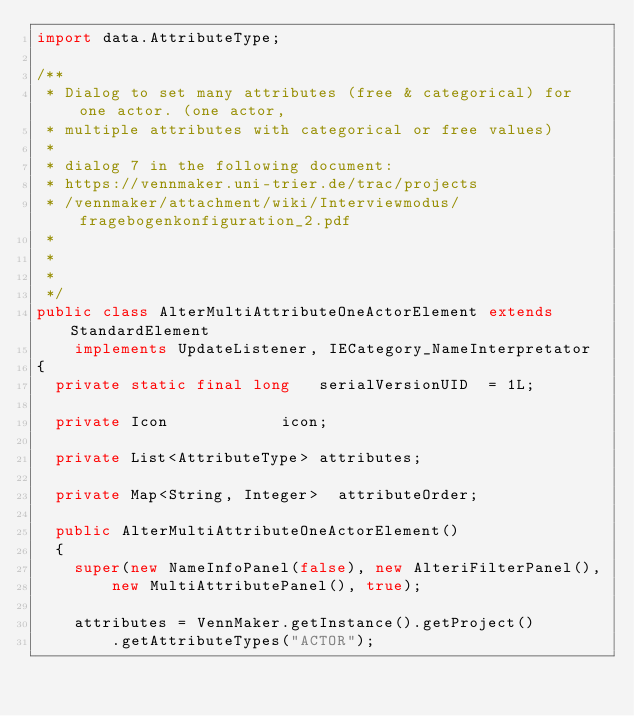<code> <loc_0><loc_0><loc_500><loc_500><_Java_>import data.AttributeType;

/**
 * Dialog to set many attributes (free & categorical) for one actor. (one actor,
 * multiple attributes with categorical or free values)
 * 
 * dialog 7 in the following document:
 * https://vennmaker.uni-trier.de/trac/projects
 * /vennmaker/attachment/wiki/Interviewmodus/fragebogenkonfiguration_2.pdf
 * 
 * 
 * 
 */
public class AlterMultiAttributeOneActorElement extends StandardElement
		implements UpdateListener, IECategory_NameInterpretator
{
	private static final long		serialVersionUID	= 1L;

	private Icon						icon;

	private List<AttributeType>	attributes;

	private Map<String, Integer>	attributeOrder;

	public AlterMultiAttributeOneActorElement()
	{
		super(new NameInfoPanel(false), new AlteriFilterPanel(),
				new MultiAttributePanel(), true);

		attributes = VennMaker.getInstance().getProject()
				.getAttributeTypes("ACTOR");
</code> 